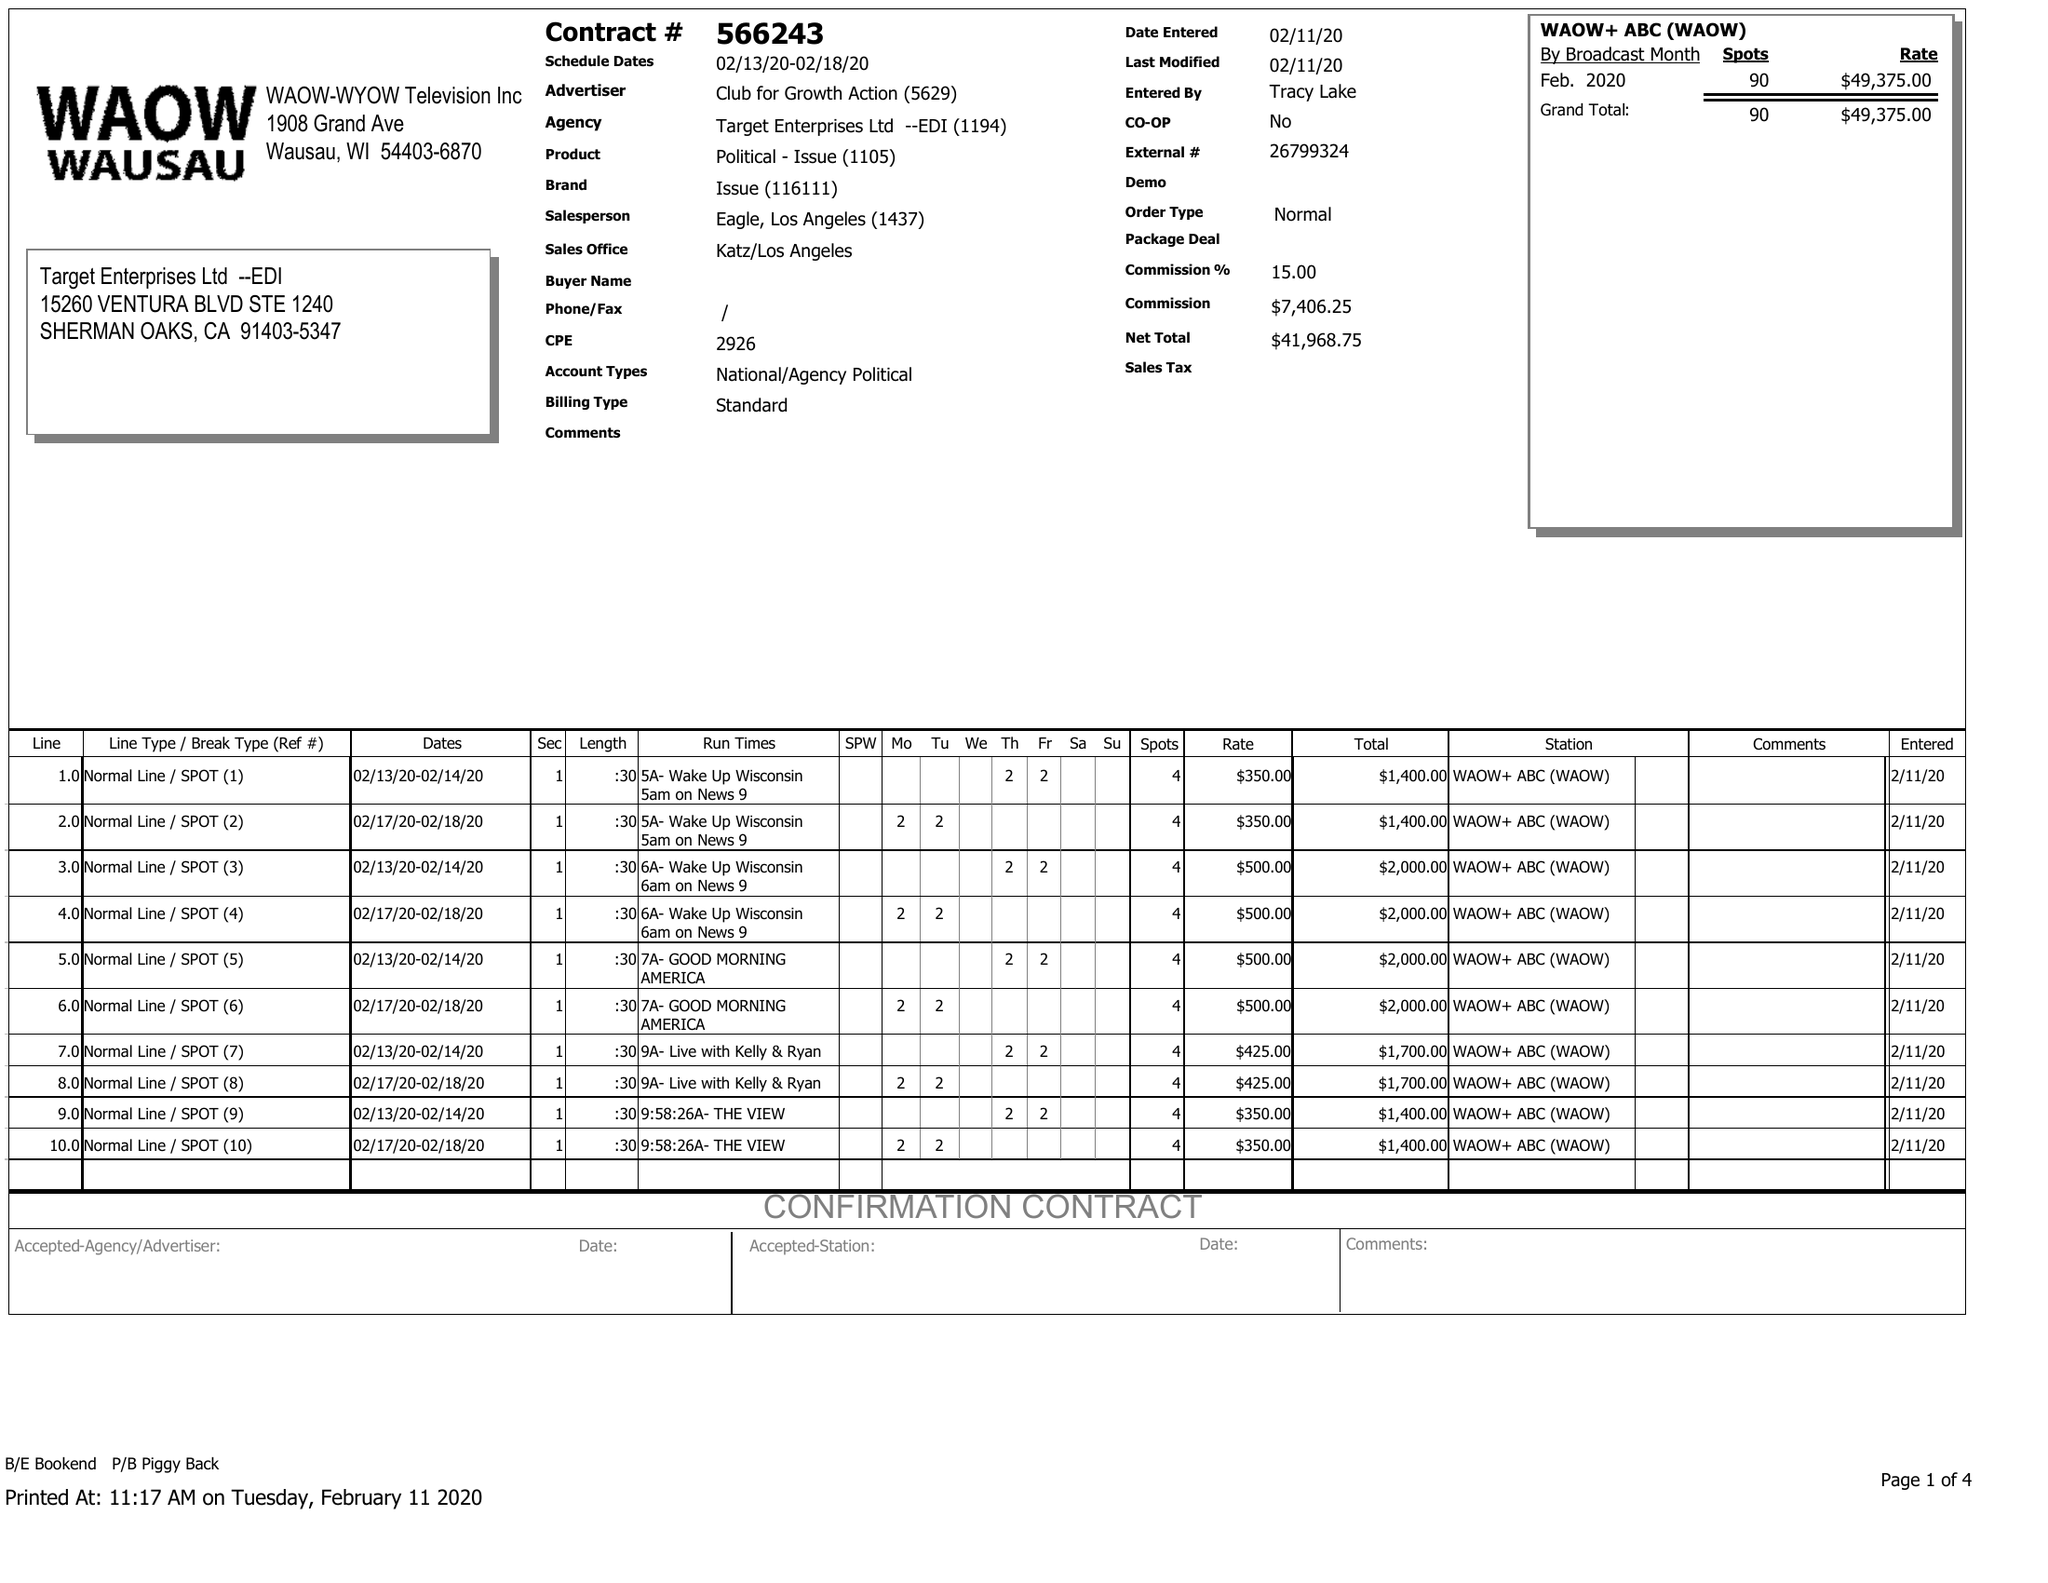What is the value for the flight_from?
Answer the question using a single word or phrase. 02/13/20 